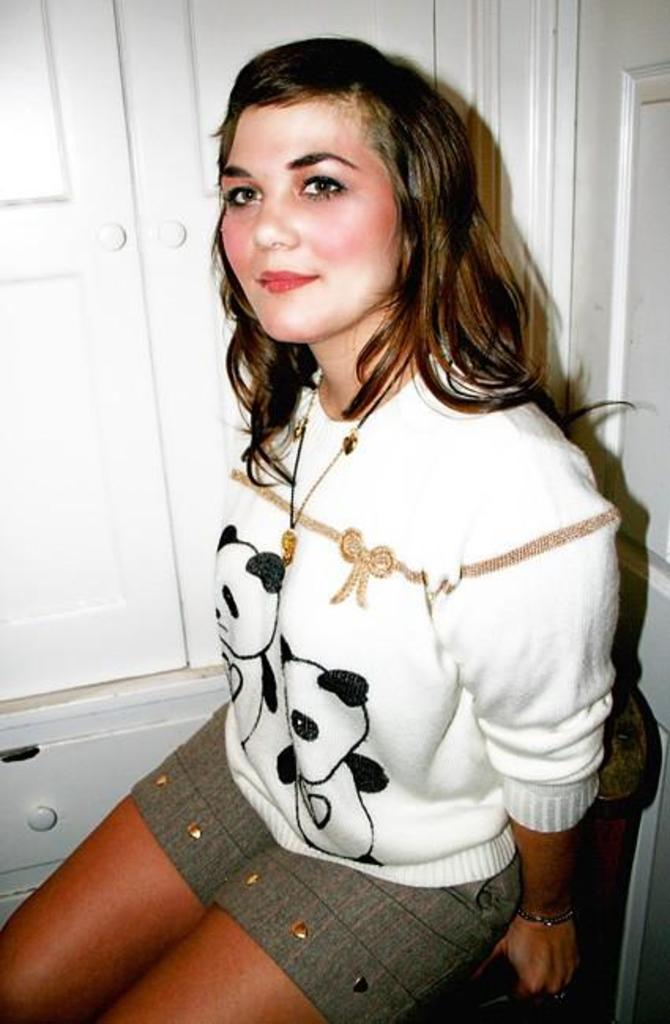What is the woman in the image doing? The woman is sitting on a chair in the image. What can be seen on the left side of the image? There are cupboards on the left side of the image. What is located on the right side of the image? There is a door on the right side of the image. What type of fish can be seen swimming near the woman in the image? There is no fish present in the image; it features a woman sitting on a chair with cupboards on the left side and a door on the right side. 